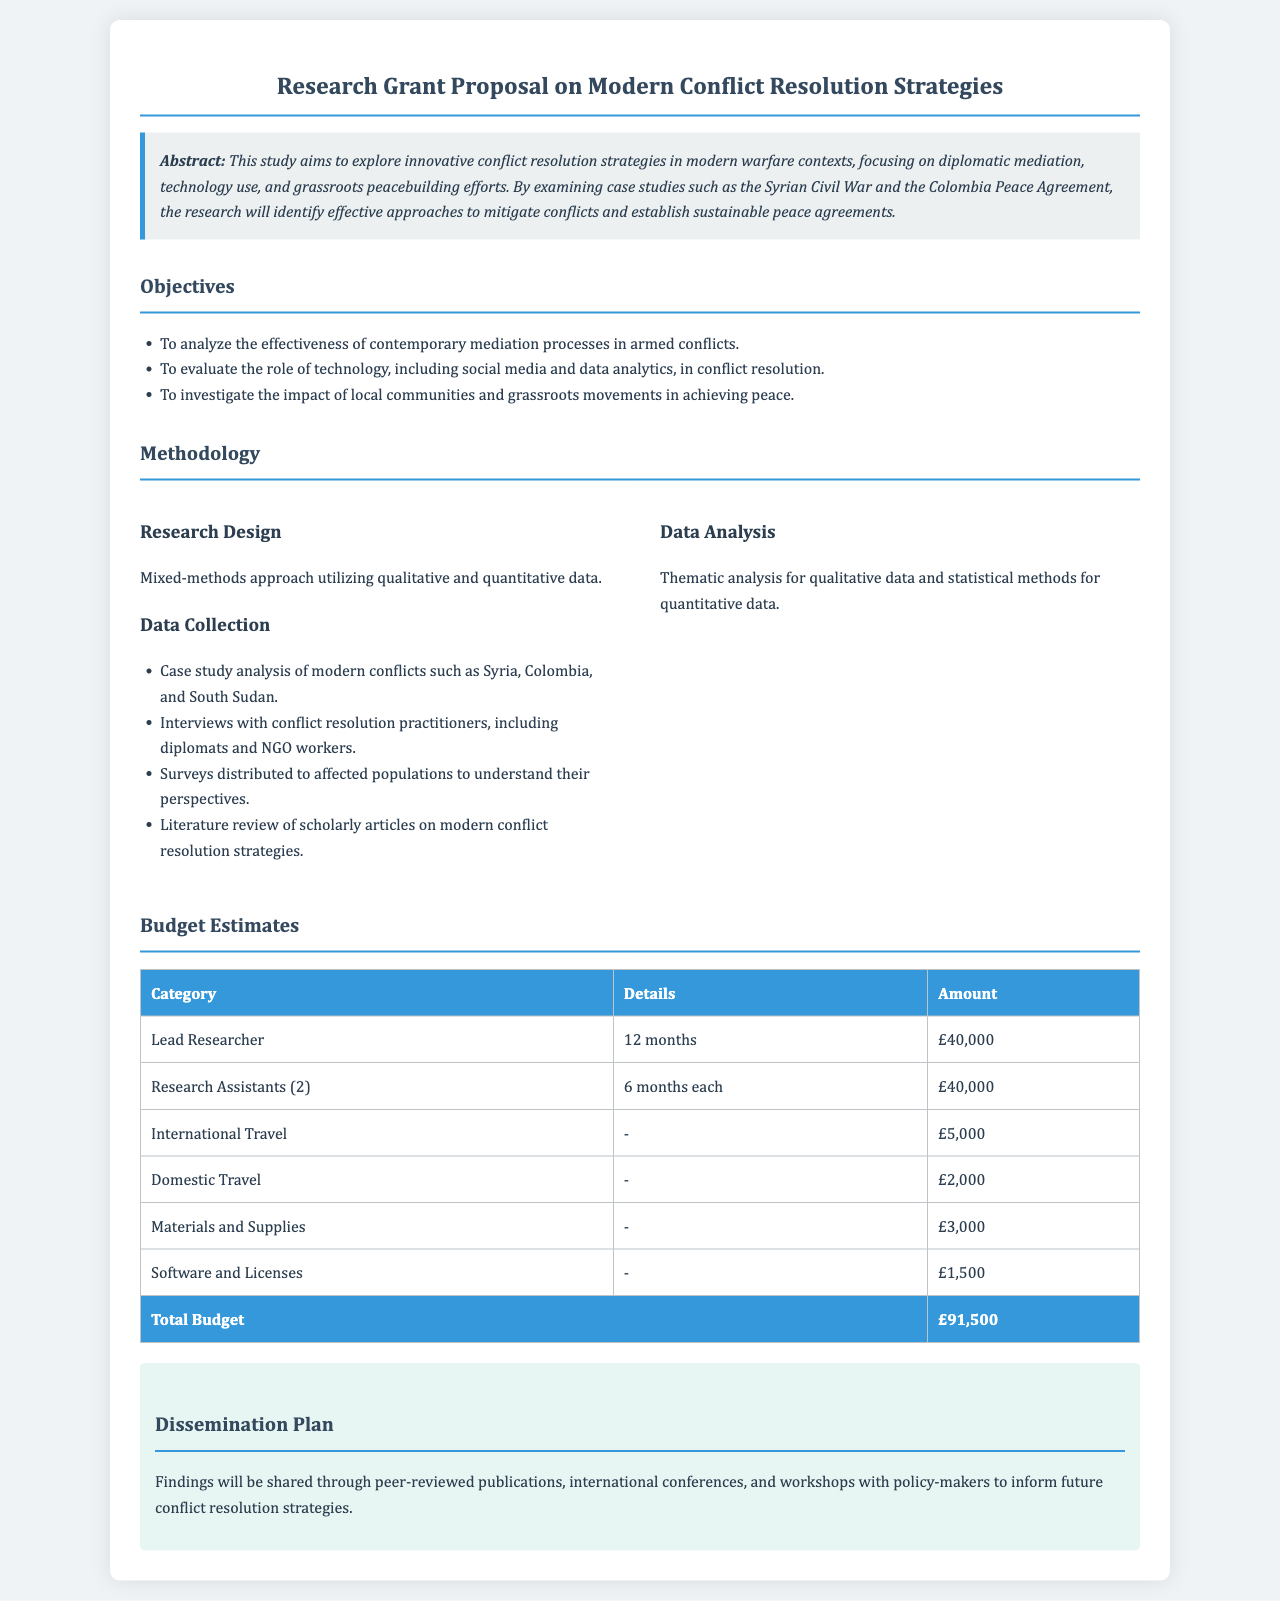What is the title of the research grant proposal? The title of the research grant proposal is explicitly stated at the top of the document, which is "Research Grant Proposal on Modern Conflict Resolution Strategies."
Answer: Research Grant Proposal on Modern Conflict Resolution Strategies What is the total budget for the study? The total budget is calculated by summing up all individual categories listed under the budget estimates section in the document.
Answer: £91,500 Which conflict case studies are examined in the research? The conflict case studies are mentioned in the abstract and methodology sections, detailing modern conflicts focused on.
Answer: Syrian Civil War, Colombia Peace Agreement How long will the lead researcher be employed? The employment duration for the lead researcher is specified in the budget estimates section.
Answer: 12 months What methodology does the study employ? The document outlines the research design used for the study, which combines different data types and methods.
Answer: Mixed-methods approach What role do local communities play in this research? The objectives section outlines the investigation aspect regarding local communities and their contributions.
Answer: Achieving peace How will the findings be disseminated? The dissemination plan states the methods of sharing findings outlined at the end of the document.
Answer: Peer-reviewed publications, international conferences How many research assistants are involved in this study? The budget estimates section specifies the number of research assistants that will participate in the research project.
Answer: 2 What type of analysis is used for qualitative data? The methodology section provides information about the specific analysis method used for qualitative data.
Answer: Thematic analysis 